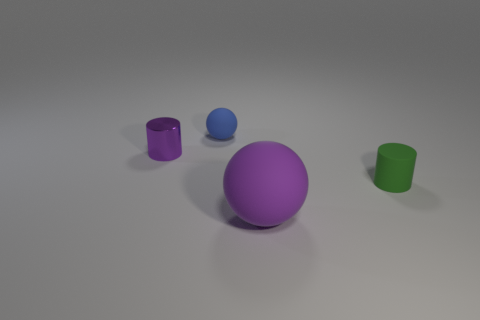Is there any other thing that has the same material as the small purple cylinder?
Your response must be concise. No. There is a object that is on the right side of the large rubber object in front of the cylinder that is right of the blue rubber thing; what is its shape?
Ensure brevity in your answer.  Cylinder. How big is the purple rubber thing?
Provide a succinct answer. Large. There is a big purple thing that is made of the same material as the tiny sphere; what shape is it?
Give a very brief answer. Sphere. Is the number of small purple things that are on the right side of the small blue rubber thing less than the number of small brown shiny balls?
Offer a terse response. No. What color is the tiny cylinder that is left of the matte cylinder?
Provide a succinct answer. Purple. There is a large sphere that is the same color as the small metallic cylinder; what is its material?
Your answer should be compact. Rubber. Is there a blue thing that has the same shape as the big purple matte thing?
Make the answer very short. Yes. How many other objects have the same shape as the large thing?
Provide a short and direct response. 1. Is the color of the big object the same as the metallic cylinder?
Provide a short and direct response. Yes. 